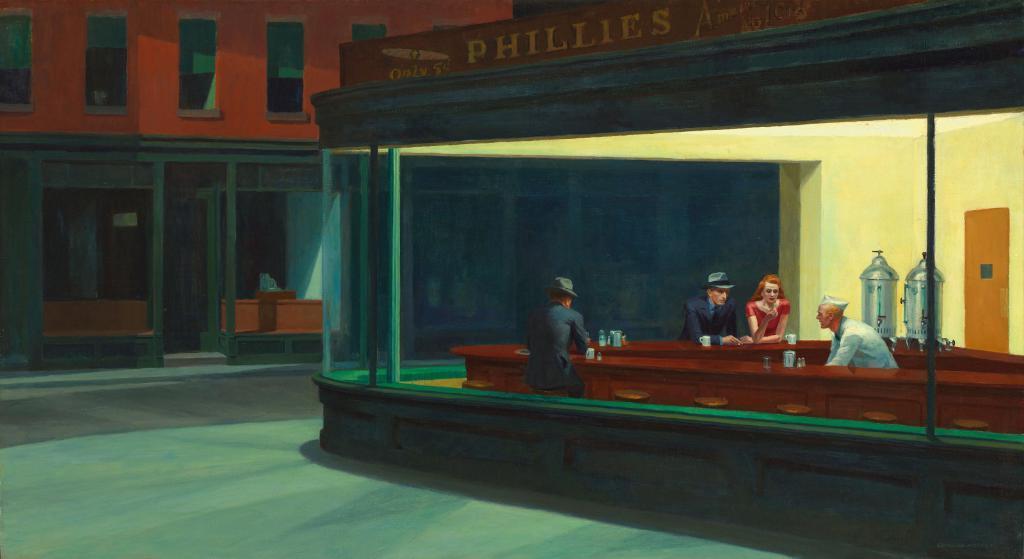Describe this image in one or two sentences. This picture is a drawing in this picture there is a shop, in that shop there are three men and a woman, beside that show there is a building. 